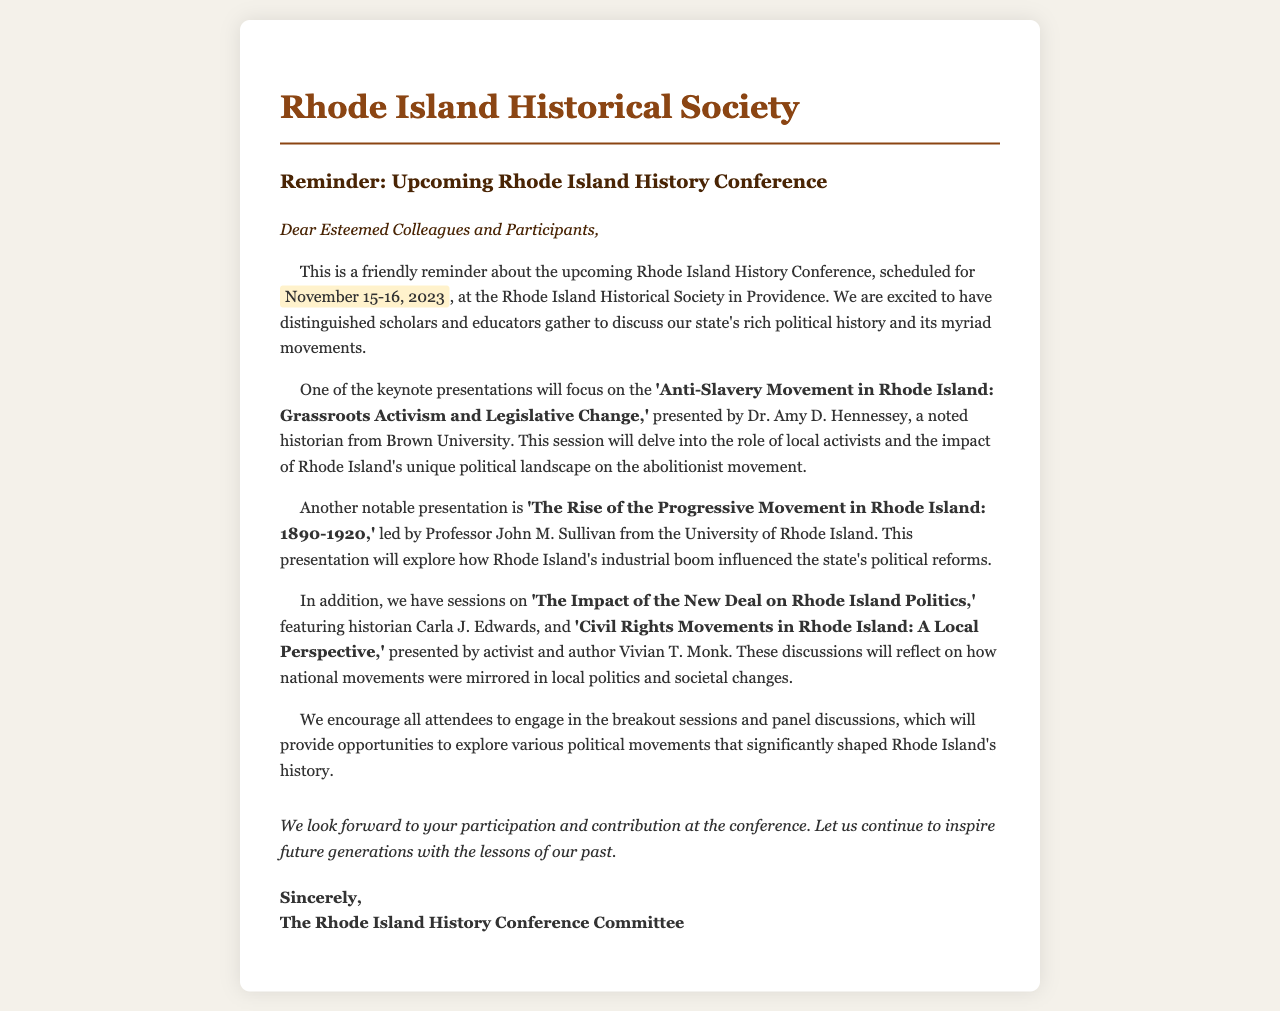What are the dates of the conference? The dates of the conference are explicitly mentioned in the document as November 15-16, 2023.
Answer: November 15-16, 2023 Who is presenting on the topic of the Anti-Slavery Movement? The document names Dr. Amy D. Hennessey as the presenter for the keynote presentation on the Anti-Slavery Movement.
Answer: Dr. Amy D. Hennessey What is the focus of Professor John M. Sullivan's presentation? The document states that Professor John M. Sullivan's presentation focuses on the Rise of the Progressive Movement in Rhode Island from 1890-1920.
Answer: The Rise of the Progressive Movement in Rhode Island: 1890-1920 Who will discuss the Civil Rights Movements in Rhode Island? The document mentions that activist and author Vivian T. Monk will present on the Civil Rights Movements in Rhode Island.
Answer: Vivian T. Monk How many keynote presentations are specifically mentioned in the letter? The letter lists four keynote presentations, indicating that there are multiple notable discussions planned.
Answer: Four What will the breakout sessions provide opportunities for? The document states that breakout sessions will provide opportunities to explore various political movements that shaped Rhode Island's history.
Answer: Explore various political movements What is the primary purpose of the letter? The primary purpose of the letter is to remind attendees about the upcoming Rhode Island History Conference and highlight significant presentations.
Answer: Reminder about the upcoming Rhode Island History Conference What institution is hosting the conference? The hosting institution for the conference is clearly stated in the document as the Rhode Island Historical Society.
Answer: Rhode Island Historical Society 